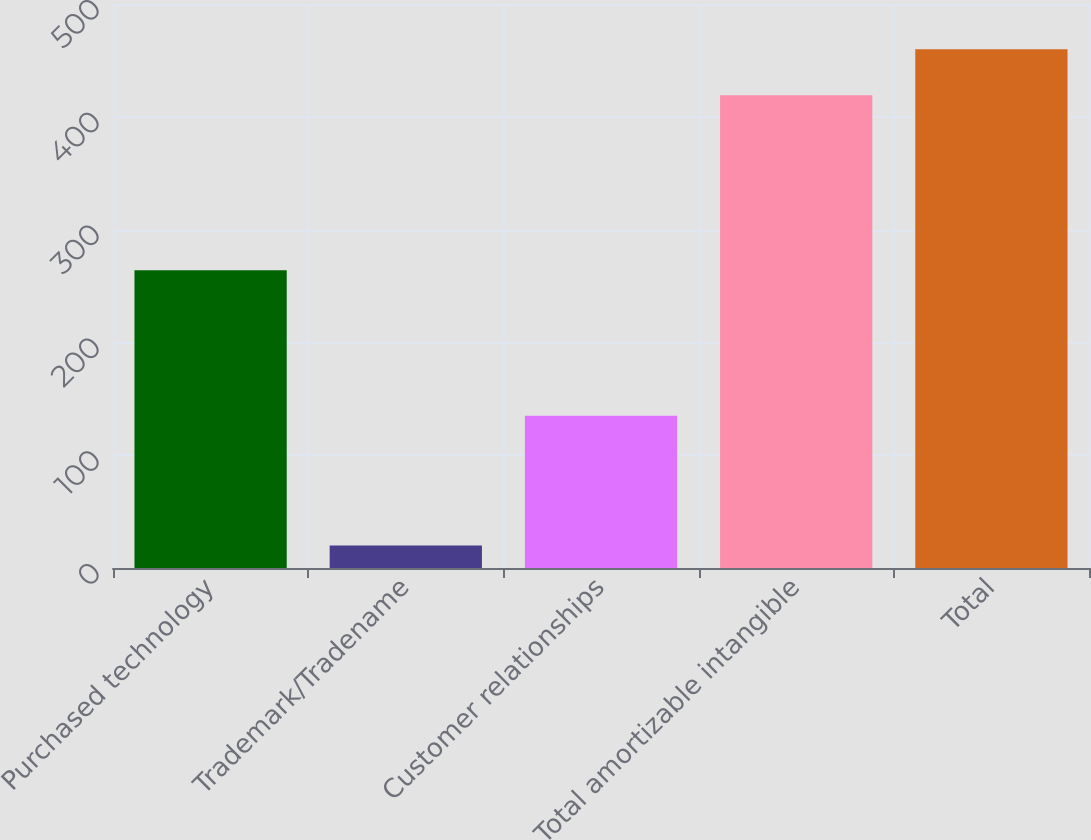<chart> <loc_0><loc_0><loc_500><loc_500><bar_chart><fcel>Purchased technology<fcel>Trademark/Tradename<fcel>Customer relationships<fcel>Total amortizable intangible<fcel>Total<nl><fcel>264<fcel>20<fcel>135<fcel>419<fcel>459.9<nl></chart> 